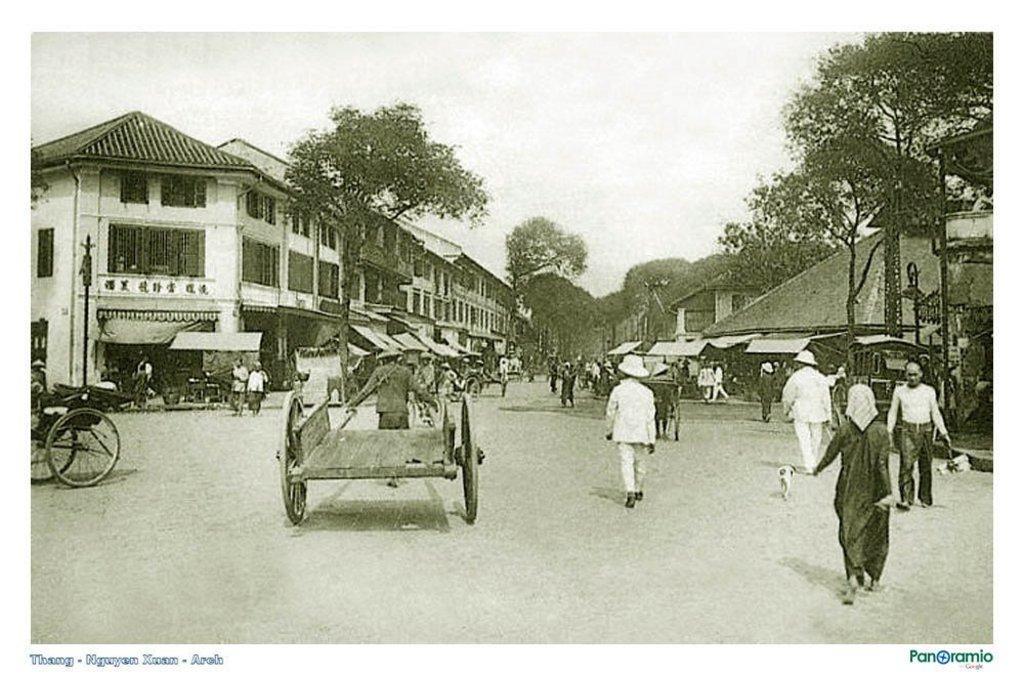Could you give a brief overview of what you see in this image? In this picture I can see the road on which there are number of people and few cycles and in the background I can see the buildings, trees and the sky. I can also see the watermarks on the bottom of this picture. 